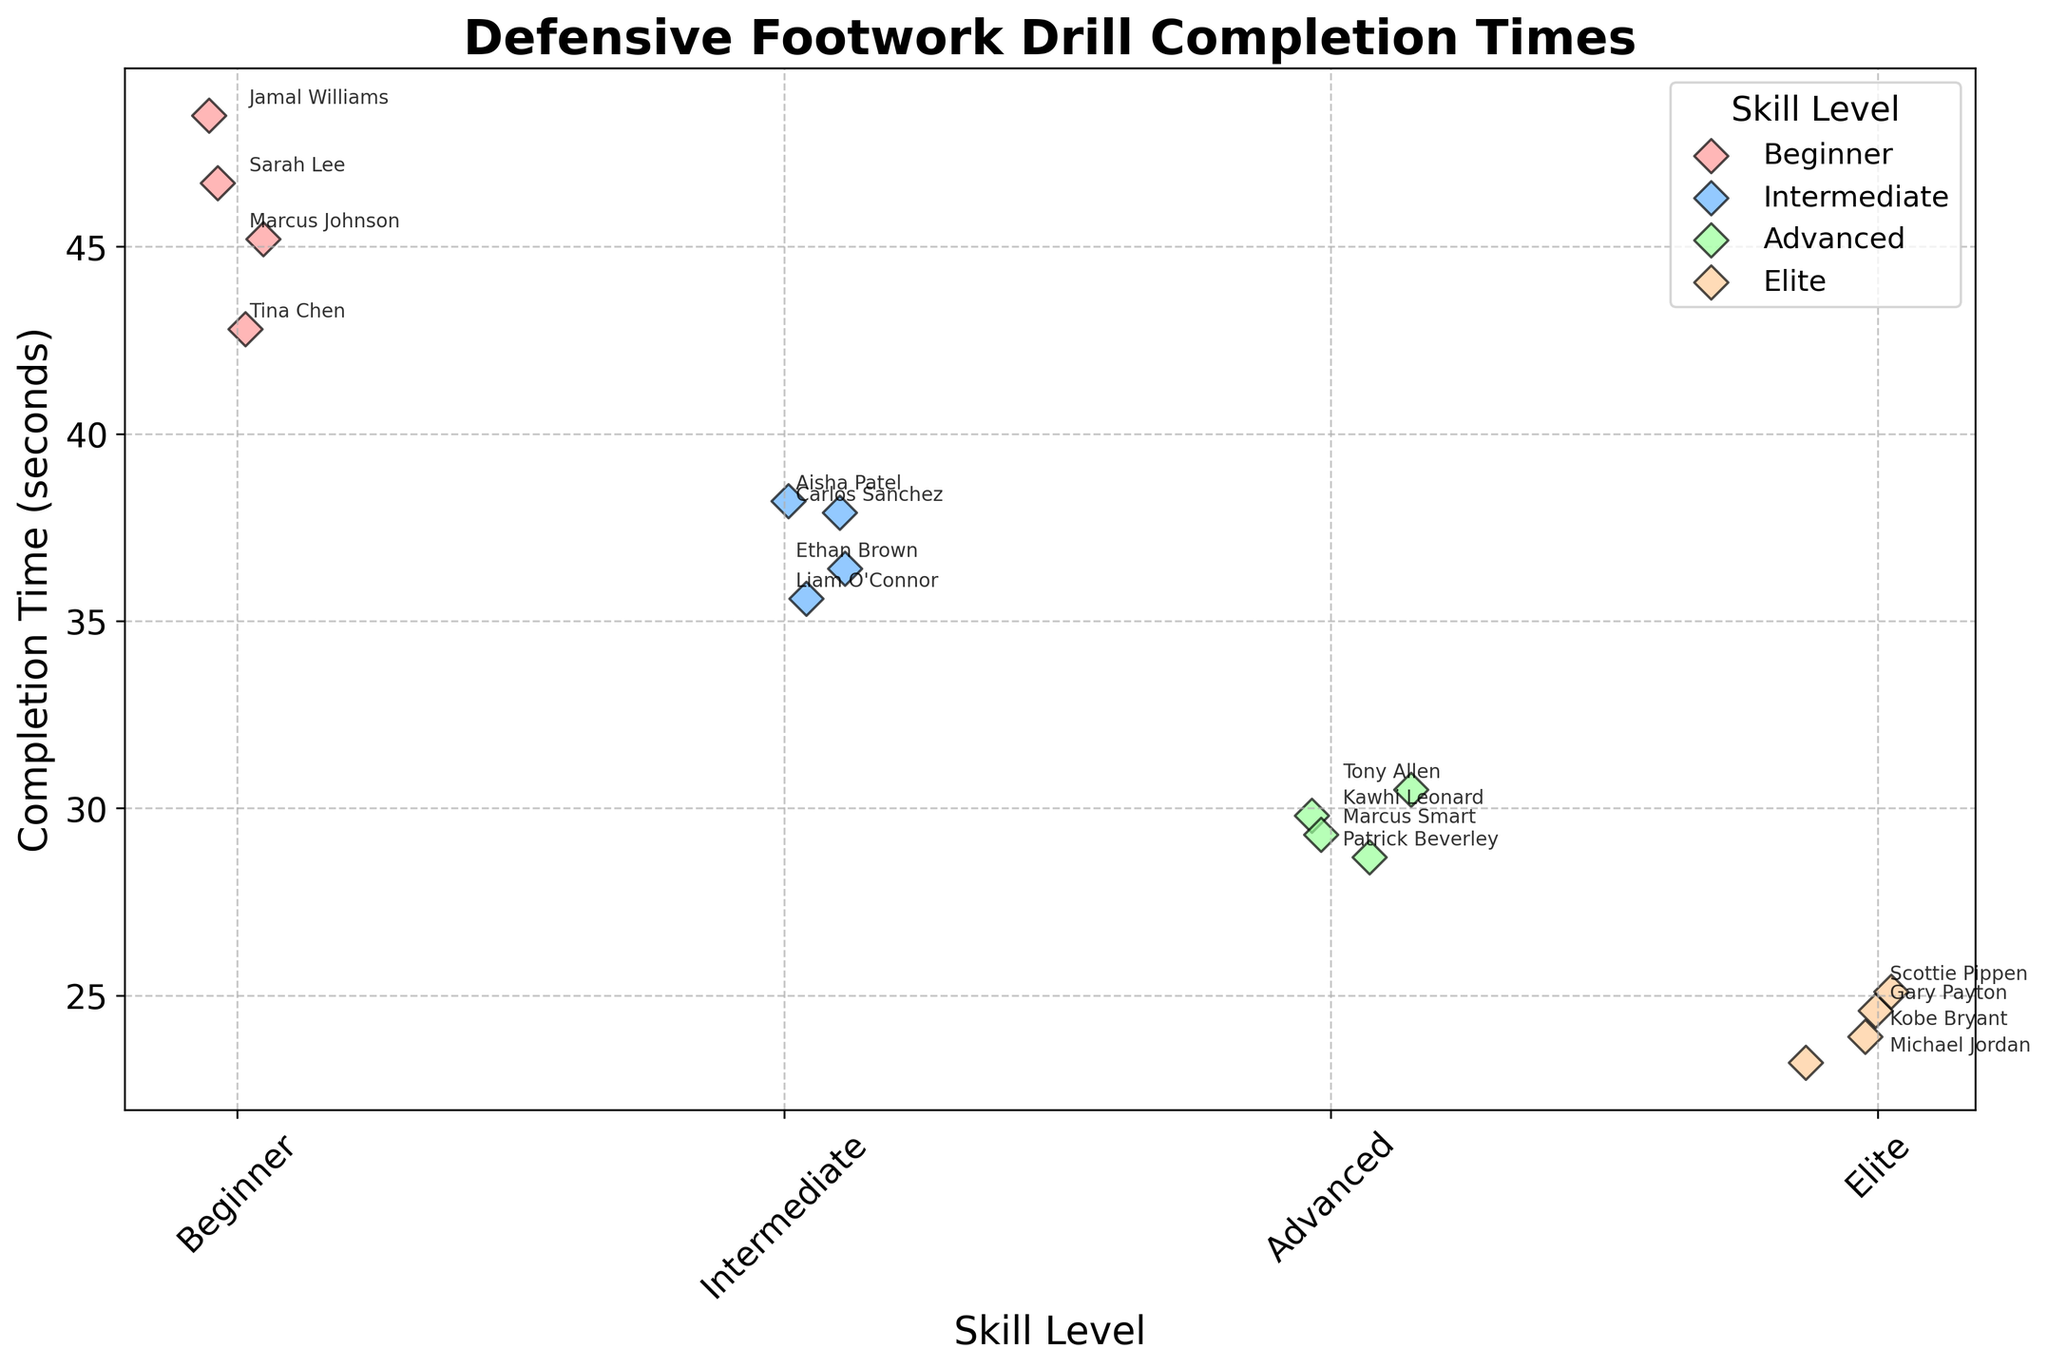What is the title of the plot? The title is typically at the top of the plot, highlighted and larger in font size for emphasis. In this case, it reads "Defensive Footwork Drill Completion Times".
Answer: Defensive Footwork Drill Completion Times Which skill level has the lowest completion time? To find this, look for the group with the lowest positioned dots along the y-axis. The lowest dot is near the 23 seconds mark in the Elite skill level, indicating that it has the lowest completion time.
Answer: Elite How many players are represented in the Beginner skill level? Count the number of distinct dots in the Beginner category along the x-axis. There are four dots in this area.
Answer: 4 What is the average completion time for the Intermediate skill level? Sum the completion times for the Intermediate players: (37.9 + 35.6 + 38.2 + 36.4) = 148.1. Divide by the number of players (4) to get the average: 148.1 / 4 = 37.025 seconds.
Answer: 37.025 Which skill level has the most variation in completion times? Variation is observed by the spread of the dots along the y-axis. The skill level with the widest vertical spread in the dots represents the greatest variation, which is the Beginner level.
Answer: Beginner Who is the fastest player in the Advanced skill level? Identify the lowest dot within the Advanced skill level section and check the annotation. It corresponds to Patrick Beverley with a time of 28.7 seconds.
Answer: Patrick Beverley Compare the fastest player in the Advanced skill level to the fastest player in the Elite skill level. What is the difference in their completion times? The fastest player in Advanced is Patrick Beverley at 28.7 seconds. The fastest player in Elite is Michael Jordan at 23.2 seconds. The difference is 28.7 - 23.2 = 5.5 seconds.
Answer: 5.5 seconds Which skill level shows the smallest range in completion times? Range is calculated by subtracting the minimum time from the maximum time within a skill level. Compare visual ranges: Elite has the smallest range, from 23.2 to 25.1 seconds (25.1 - 23.2 = 1.9 seconds).
Answer: Elite What are the completion times of the players in the Advanced skill level? Read the y-values of the dots within the Advanced category and check their annotations: Kawhi Leonard (29.8), Tony Allen (30.5), Patrick Beverley (28.7), Marcus Smart (29.3).
Answer: 29.8, 30.5, 28.7, 29.3 How does the median completion time for the Beginner skill level compare to the median completion time for the Advanced skill level? Arrange the times in ascending order. Beginner: 42.8, 45.2, 46.7, 48.5 (Median is (45.2 + 46.7) / 2 = 45.95). Advanced: 28.7, 29.3, 29.8, 30.5 (Median is (29.3 + 29.8) / 2 = 29.55). Compare the medians 45.95 vs 29.55; the Beginner median is higher.
Answer: Beginner's median is higher 